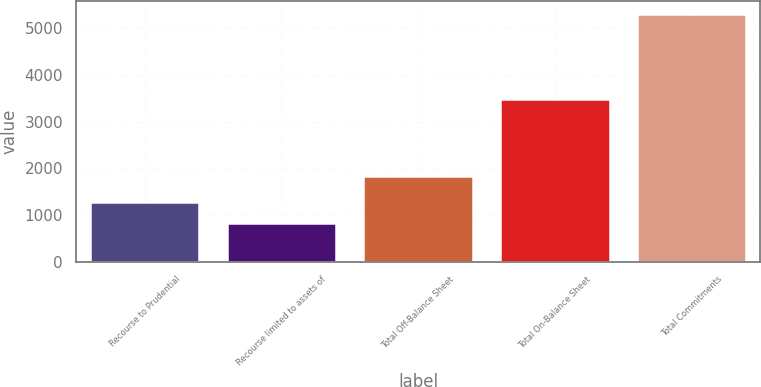Convert chart. <chart><loc_0><loc_0><loc_500><loc_500><bar_chart><fcel>Recourse to Prudential<fcel>Recourse limited to assets of<fcel>Total Off-Balance Sheet<fcel>Total On-Balance Sheet<fcel>Total Commitments<nl><fcel>1271.4<fcel>822<fcel>1837<fcel>3479<fcel>5316<nl></chart> 